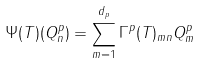<formula> <loc_0><loc_0><loc_500><loc_500>\Psi ( T ) ( Q ^ { p } _ { n } ) = \sum _ { m = 1 } ^ { d _ { p } } \Gamma ^ { p } ( T ) _ { m n } Q ^ { p } _ { m }</formula> 